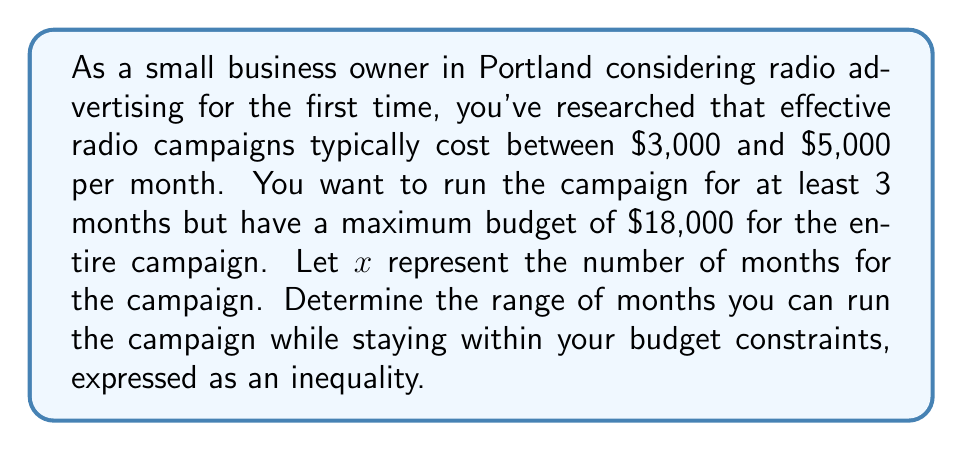Help me with this question. Let's approach this step-by-step:

1) First, we need to set up our inequalities based on the given information:

   - The monthly cost is between $3,000 and $5,000
   - The campaign should run for at least 3 months
   - The total budget is $18,000 maximum

2) Let's express these as inequalities:

   $3000x \leq \text{total cost} \leq 5000x$
   $x \geq 3$
   $\text{total cost} \leq 18000$

3) Combining these inequalities:

   $3000x \leq 18000$ and $5000x \leq 18000$ and $x \geq 3$

4) Let's solve each part:

   From $3000x \leq 18000$:
   $x \leq 6$

   From $5000x \leq 18000$:
   $x \leq 3.6$

   And we already have $x \geq 3$

5) Combining these results:

   $3 \leq x \leq 3.6$

6) Since $x$ represents months, we need to round down to the nearest whole number:

   $3 \leq x \leq 3$

This means you can run the campaign for exactly 3 months while staying within your budget constraints.
Answer: $3 \leq x \leq 3$, where $x$ represents the number of months for the radio advertising campaign. 